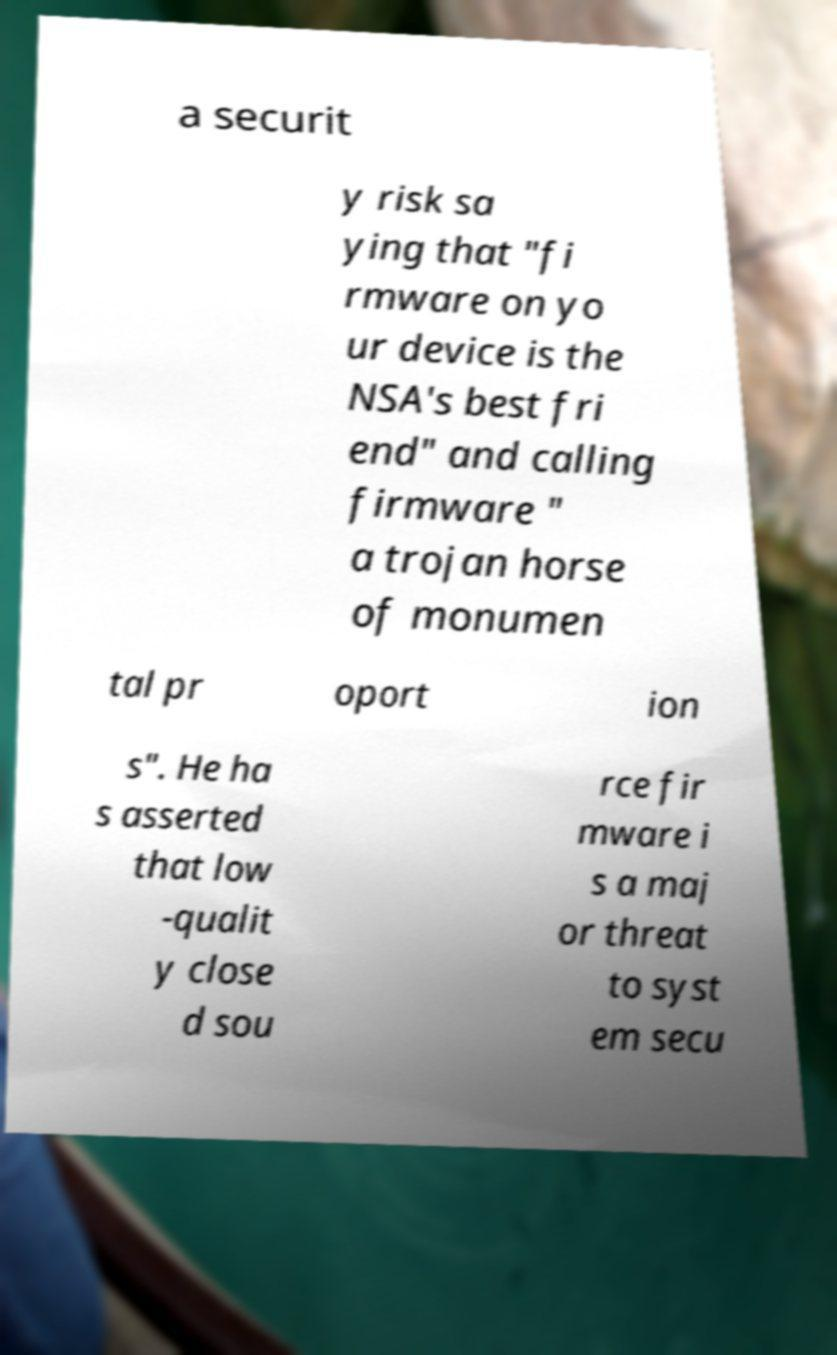Can you read and provide the text displayed in the image?This photo seems to have some interesting text. Can you extract and type it out for me? a securit y risk sa ying that "fi rmware on yo ur device is the NSA's best fri end" and calling firmware " a trojan horse of monumen tal pr oport ion s". He ha s asserted that low -qualit y close d sou rce fir mware i s a maj or threat to syst em secu 